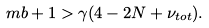<formula> <loc_0><loc_0><loc_500><loc_500>\ m b + 1 > \gamma ( 4 - 2 N + \nu _ { t o t } ) .</formula> 